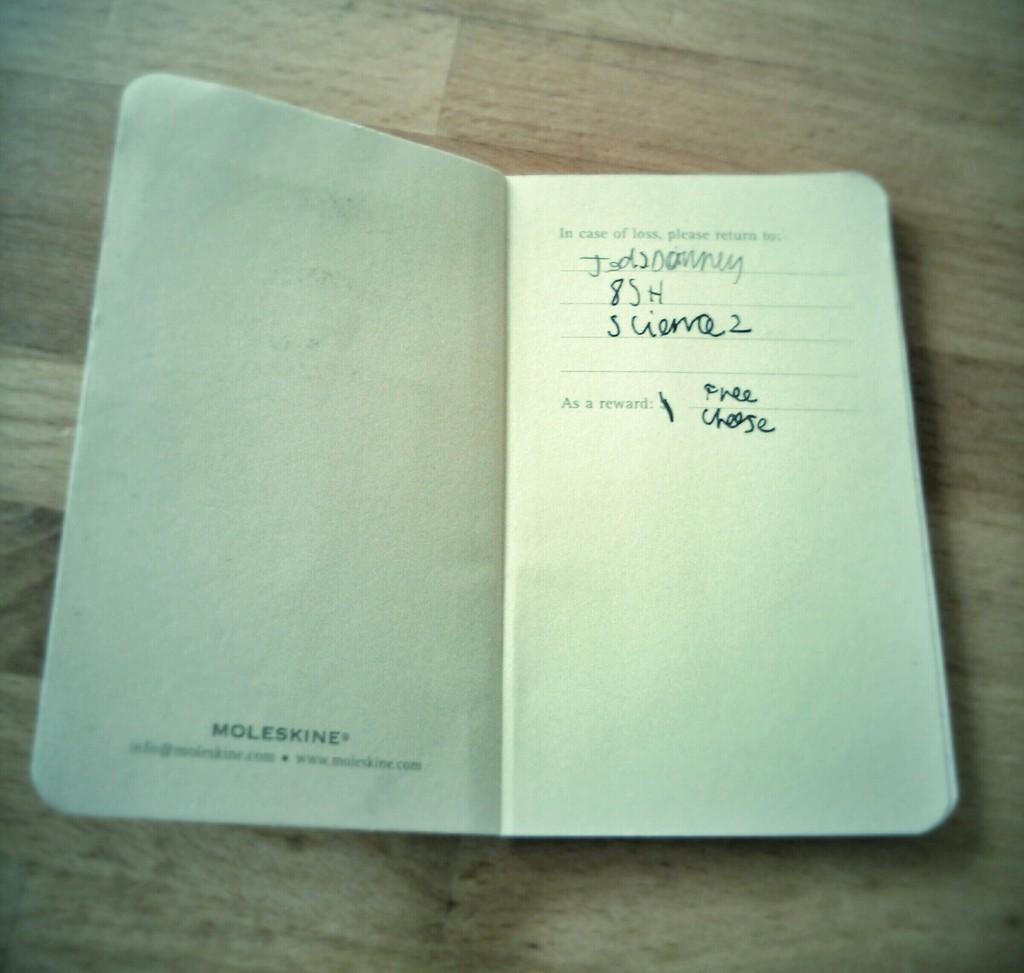<image>
Create a compact narrative representing the image presented. a page from a journal that says free cheese in it 